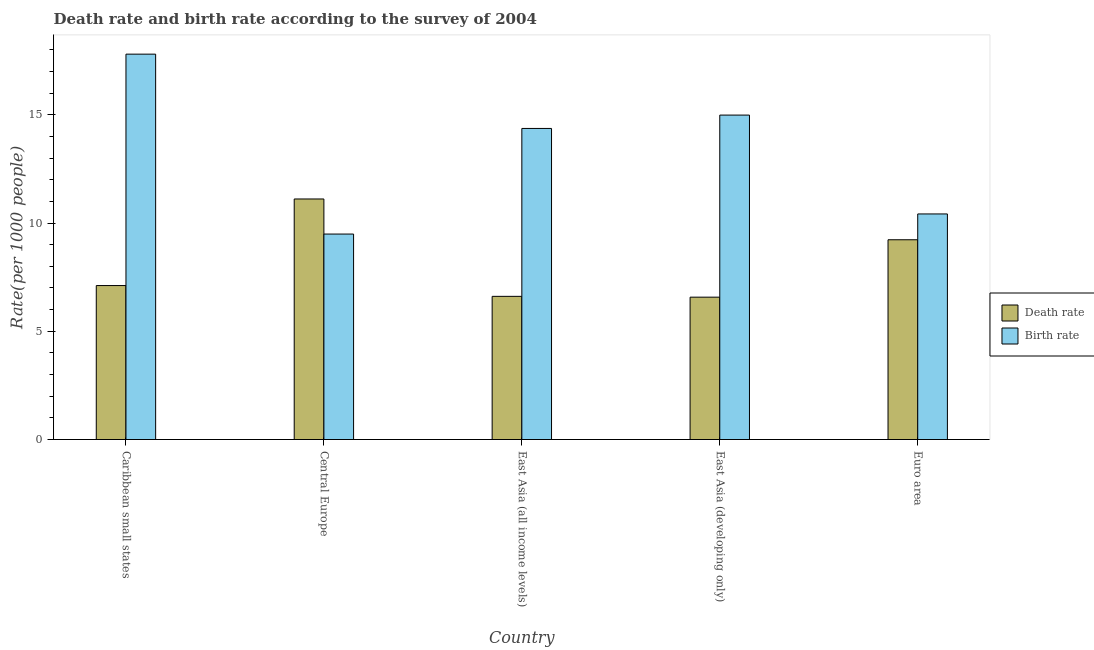Are the number of bars per tick equal to the number of legend labels?
Make the answer very short. Yes. How many bars are there on the 2nd tick from the right?
Your response must be concise. 2. What is the label of the 3rd group of bars from the left?
Provide a short and direct response. East Asia (all income levels). What is the birth rate in East Asia (developing only)?
Your response must be concise. 14.99. Across all countries, what is the maximum death rate?
Keep it short and to the point. 11.11. Across all countries, what is the minimum death rate?
Make the answer very short. 6.58. In which country was the birth rate maximum?
Offer a very short reply. Caribbean small states. In which country was the birth rate minimum?
Keep it short and to the point. Central Europe. What is the total birth rate in the graph?
Give a very brief answer. 67.07. What is the difference between the birth rate in Central Europe and that in Euro area?
Your answer should be compact. -0.93. What is the difference between the birth rate in Caribbean small states and the death rate in Central Europe?
Your answer should be compact. 6.69. What is the average death rate per country?
Your answer should be compact. 8.13. What is the difference between the birth rate and death rate in East Asia (developing only)?
Offer a terse response. 8.41. What is the ratio of the birth rate in Caribbean small states to that in East Asia (all income levels)?
Keep it short and to the point. 1.24. Is the difference between the birth rate in Caribbean small states and East Asia (all income levels) greater than the difference between the death rate in Caribbean small states and East Asia (all income levels)?
Provide a succinct answer. Yes. What is the difference between the highest and the second highest death rate?
Provide a short and direct response. 1.88. What is the difference between the highest and the lowest birth rate?
Make the answer very short. 8.31. What does the 2nd bar from the left in East Asia (all income levels) represents?
Your answer should be compact. Birth rate. What does the 1st bar from the right in Euro area represents?
Make the answer very short. Birth rate. How many bars are there?
Your answer should be very brief. 10. Are all the bars in the graph horizontal?
Ensure brevity in your answer.  No. How many countries are there in the graph?
Offer a terse response. 5. What is the difference between two consecutive major ticks on the Y-axis?
Offer a very short reply. 5. Does the graph contain any zero values?
Provide a succinct answer. No. Does the graph contain grids?
Your answer should be very brief. No. How are the legend labels stacked?
Provide a short and direct response. Vertical. What is the title of the graph?
Your response must be concise. Death rate and birth rate according to the survey of 2004. Does "Electricity and heat production" appear as one of the legend labels in the graph?
Offer a terse response. No. What is the label or title of the Y-axis?
Give a very brief answer. Rate(per 1000 people). What is the Rate(per 1000 people) in Death rate in Caribbean small states?
Make the answer very short. 7.11. What is the Rate(per 1000 people) of Birth rate in Caribbean small states?
Give a very brief answer. 17.8. What is the Rate(per 1000 people) of Death rate in Central Europe?
Provide a short and direct response. 11.11. What is the Rate(per 1000 people) in Birth rate in Central Europe?
Provide a succinct answer. 9.49. What is the Rate(per 1000 people) of Death rate in East Asia (all income levels)?
Your response must be concise. 6.61. What is the Rate(per 1000 people) in Birth rate in East Asia (all income levels)?
Give a very brief answer. 14.37. What is the Rate(per 1000 people) in Death rate in East Asia (developing only)?
Ensure brevity in your answer.  6.58. What is the Rate(per 1000 people) in Birth rate in East Asia (developing only)?
Your answer should be very brief. 14.99. What is the Rate(per 1000 people) in Death rate in Euro area?
Keep it short and to the point. 9.23. What is the Rate(per 1000 people) in Birth rate in Euro area?
Provide a succinct answer. 10.42. Across all countries, what is the maximum Rate(per 1000 people) of Death rate?
Provide a short and direct response. 11.11. Across all countries, what is the maximum Rate(per 1000 people) of Birth rate?
Offer a terse response. 17.8. Across all countries, what is the minimum Rate(per 1000 people) in Death rate?
Offer a terse response. 6.58. Across all countries, what is the minimum Rate(per 1000 people) in Birth rate?
Offer a very short reply. 9.49. What is the total Rate(per 1000 people) of Death rate in the graph?
Offer a very short reply. 40.64. What is the total Rate(per 1000 people) of Birth rate in the graph?
Keep it short and to the point. 67.07. What is the difference between the Rate(per 1000 people) of Death rate in Caribbean small states and that in Central Europe?
Provide a succinct answer. -4. What is the difference between the Rate(per 1000 people) of Birth rate in Caribbean small states and that in Central Europe?
Your answer should be very brief. 8.31. What is the difference between the Rate(per 1000 people) in Death rate in Caribbean small states and that in East Asia (all income levels)?
Offer a terse response. 0.5. What is the difference between the Rate(per 1000 people) of Birth rate in Caribbean small states and that in East Asia (all income levels)?
Make the answer very short. 3.43. What is the difference between the Rate(per 1000 people) in Death rate in Caribbean small states and that in East Asia (developing only)?
Keep it short and to the point. 0.54. What is the difference between the Rate(per 1000 people) in Birth rate in Caribbean small states and that in East Asia (developing only)?
Give a very brief answer. 2.82. What is the difference between the Rate(per 1000 people) of Death rate in Caribbean small states and that in Euro area?
Make the answer very short. -2.12. What is the difference between the Rate(per 1000 people) of Birth rate in Caribbean small states and that in Euro area?
Give a very brief answer. 7.38. What is the difference between the Rate(per 1000 people) in Death rate in Central Europe and that in East Asia (all income levels)?
Offer a very short reply. 4.5. What is the difference between the Rate(per 1000 people) of Birth rate in Central Europe and that in East Asia (all income levels)?
Ensure brevity in your answer.  -4.88. What is the difference between the Rate(per 1000 people) of Death rate in Central Europe and that in East Asia (developing only)?
Give a very brief answer. 4.54. What is the difference between the Rate(per 1000 people) in Birth rate in Central Europe and that in East Asia (developing only)?
Give a very brief answer. -5.5. What is the difference between the Rate(per 1000 people) in Death rate in Central Europe and that in Euro area?
Provide a succinct answer. 1.88. What is the difference between the Rate(per 1000 people) of Birth rate in Central Europe and that in Euro area?
Provide a short and direct response. -0.93. What is the difference between the Rate(per 1000 people) of Death rate in East Asia (all income levels) and that in East Asia (developing only)?
Your answer should be compact. 0.04. What is the difference between the Rate(per 1000 people) in Birth rate in East Asia (all income levels) and that in East Asia (developing only)?
Your response must be concise. -0.62. What is the difference between the Rate(per 1000 people) in Death rate in East Asia (all income levels) and that in Euro area?
Provide a succinct answer. -2.61. What is the difference between the Rate(per 1000 people) in Birth rate in East Asia (all income levels) and that in Euro area?
Provide a succinct answer. 3.95. What is the difference between the Rate(per 1000 people) in Death rate in East Asia (developing only) and that in Euro area?
Provide a succinct answer. -2.65. What is the difference between the Rate(per 1000 people) of Birth rate in East Asia (developing only) and that in Euro area?
Offer a terse response. 4.57. What is the difference between the Rate(per 1000 people) of Death rate in Caribbean small states and the Rate(per 1000 people) of Birth rate in Central Europe?
Provide a succinct answer. -2.38. What is the difference between the Rate(per 1000 people) in Death rate in Caribbean small states and the Rate(per 1000 people) in Birth rate in East Asia (all income levels)?
Provide a short and direct response. -7.26. What is the difference between the Rate(per 1000 people) in Death rate in Caribbean small states and the Rate(per 1000 people) in Birth rate in East Asia (developing only)?
Ensure brevity in your answer.  -7.87. What is the difference between the Rate(per 1000 people) in Death rate in Caribbean small states and the Rate(per 1000 people) in Birth rate in Euro area?
Your answer should be very brief. -3.31. What is the difference between the Rate(per 1000 people) in Death rate in Central Europe and the Rate(per 1000 people) in Birth rate in East Asia (all income levels)?
Ensure brevity in your answer.  -3.26. What is the difference between the Rate(per 1000 people) of Death rate in Central Europe and the Rate(per 1000 people) of Birth rate in East Asia (developing only)?
Your answer should be compact. -3.88. What is the difference between the Rate(per 1000 people) of Death rate in Central Europe and the Rate(per 1000 people) of Birth rate in Euro area?
Your answer should be very brief. 0.69. What is the difference between the Rate(per 1000 people) in Death rate in East Asia (all income levels) and the Rate(per 1000 people) in Birth rate in East Asia (developing only)?
Provide a succinct answer. -8.37. What is the difference between the Rate(per 1000 people) of Death rate in East Asia (all income levels) and the Rate(per 1000 people) of Birth rate in Euro area?
Provide a short and direct response. -3.81. What is the difference between the Rate(per 1000 people) in Death rate in East Asia (developing only) and the Rate(per 1000 people) in Birth rate in Euro area?
Make the answer very short. -3.84. What is the average Rate(per 1000 people) in Death rate per country?
Keep it short and to the point. 8.13. What is the average Rate(per 1000 people) in Birth rate per country?
Keep it short and to the point. 13.41. What is the difference between the Rate(per 1000 people) of Death rate and Rate(per 1000 people) of Birth rate in Caribbean small states?
Provide a succinct answer. -10.69. What is the difference between the Rate(per 1000 people) of Death rate and Rate(per 1000 people) of Birth rate in Central Europe?
Provide a succinct answer. 1.62. What is the difference between the Rate(per 1000 people) in Death rate and Rate(per 1000 people) in Birth rate in East Asia (all income levels)?
Your answer should be very brief. -7.76. What is the difference between the Rate(per 1000 people) of Death rate and Rate(per 1000 people) of Birth rate in East Asia (developing only)?
Your response must be concise. -8.41. What is the difference between the Rate(per 1000 people) of Death rate and Rate(per 1000 people) of Birth rate in Euro area?
Provide a short and direct response. -1.19. What is the ratio of the Rate(per 1000 people) in Death rate in Caribbean small states to that in Central Europe?
Provide a short and direct response. 0.64. What is the ratio of the Rate(per 1000 people) in Birth rate in Caribbean small states to that in Central Europe?
Give a very brief answer. 1.88. What is the ratio of the Rate(per 1000 people) of Death rate in Caribbean small states to that in East Asia (all income levels)?
Your answer should be very brief. 1.08. What is the ratio of the Rate(per 1000 people) in Birth rate in Caribbean small states to that in East Asia (all income levels)?
Your answer should be compact. 1.24. What is the ratio of the Rate(per 1000 people) in Death rate in Caribbean small states to that in East Asia (developing only)?
Your response must be concise. 1.08. What is the ratio of the Rate(per 1000 people) of Birth rate in Caribbean small states to that in East Asia (developing only)?
Provide a succinct answer. 1.19. What is the ratio of the Rate(per 1000 people) in Death rate in Caribbean small states to that in Euro area?
Provide a short and direct response. 0.77. What is the ratio of the Rate(per 1000 people) of Birth rate in Caribbean small states to that in Euro area?
Give a very brief answer. 1.71. What is the ratio of the Rate(per 1000 people) in Death rate in Central Europe to that in East Asia (all income levels)?
Your answer should be very brief. 1.68. What is the ratio of the Rate(per 1000 people) of Birth rate in Central Europe to that in East Asia (all income levels)?
Your response must be concise. 0.66. What is the ratio of the Rate(per 1000 people) in Death rate in Central Europe to that in East Asia (developing only)?
Your answer should be compact. 1.69. What is the ratio of the Rate(per 1000 people) in Birth rate in Central Europe to that in East Asia (developing only)?
Ensure brevity in your answer.  0.63. What is the ratio of the Rate(per 1000 people) of Death rate in Central Europe to that in Euro area?
Your response must be concise. 1.2. What is the ratio of the Rate(per 1000 people) of Birth rate in Central Europe to that in Euro area?
Ensure brevity in your answer.  0.91. What is the ratio of the Rate(per 1000 people) in Birth rate in East Asia (all income levels) to that in East Asia (developing only)?
Offer a terse response. 0.96. What is the ratio of the Rate(per 1000 people) in Death rate in East Asia (all income levels) to that in Euro area?
Give a very brief answer. 0.72. What is the ratio of the Rate(per 1000 people) of Birth rate in East Asia (all income levels) to that in Euro area?
Provide a succinct answer. 1.38. What is the ratio of the Rate(per 1000 people) in Death rate in East Asia (developing only) to that in Euro area?
Your answer should be very brief. 0.71. What is the ratio of the Rate(per 1000 people) of Birth rate in East Asia (developing only) to that in Euro area?
Provide a short and direct response. 1.44. What is the difference between the highest and the second highest Rate(per 1000 people) in Death rate?
Your answer should be very brief. 1.88. What is the difference between the highest and the second highest Rate(per 1000 people) of Birth rate?
Ensure brevity in your answer.  2.82. What is the difference between the highest and the lowest Rate(per 1000 people) in Death rate?
Give a very brief answer. 4.54. What is the difference between the highest and the lowest Rate(per 1000 people) of Birth rate?
Your response must be concise. 8.31. 